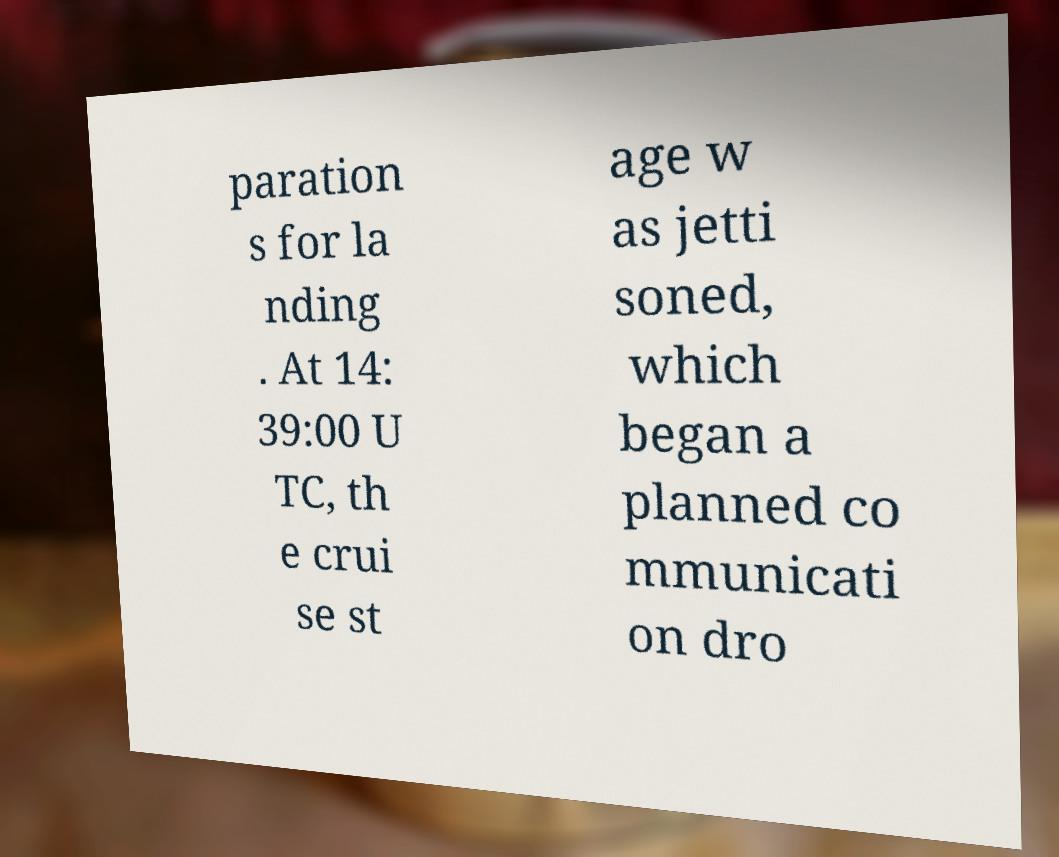What messages or text are displayed in this image? I need them in a readable, typed format. paration s for la nding . At 14: 39:00 U TC, th e crui se st age w as jetti soned, which began a planned co mmunicati on dro 